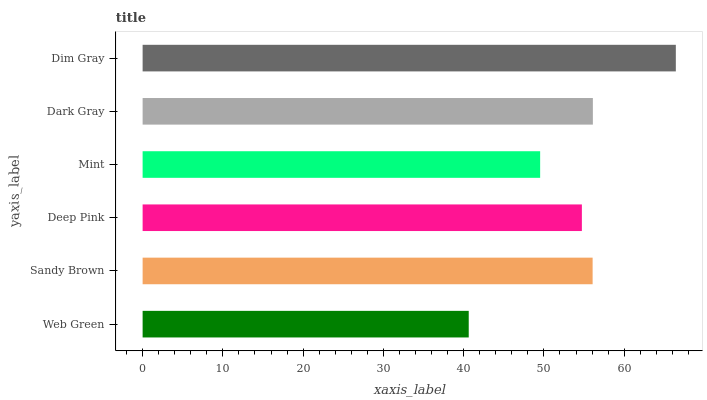Is Web Green the minimum?
Answer yes or no. Yes. Is Dim Gray the maximum?
Answer yes or no. Yes. Is Sandy Brown the minimum?
Answer yes or no. No. Is Sandy Brown the maximum?
Answer yes or no. No. Is Sandy Brown greater than Web Green?
Answer yes or no. Yes. Is Web Green less than Sandy Brown?
Answer yes or no. Yes. Is Web Green greater than Sandy Brown?
Answer yes or no. No. Is Sandy Brown less than Web Green?
Answer yes or no. No. Is Sandy Brown the high median?
Answer yes or no. Yes. Is Deep Pink the low median?
Answer yes or no. Yes. Is Mint the high median?
Answer yes or no. No. Is Dim Gray the low median?
Answer yes or no. No. 